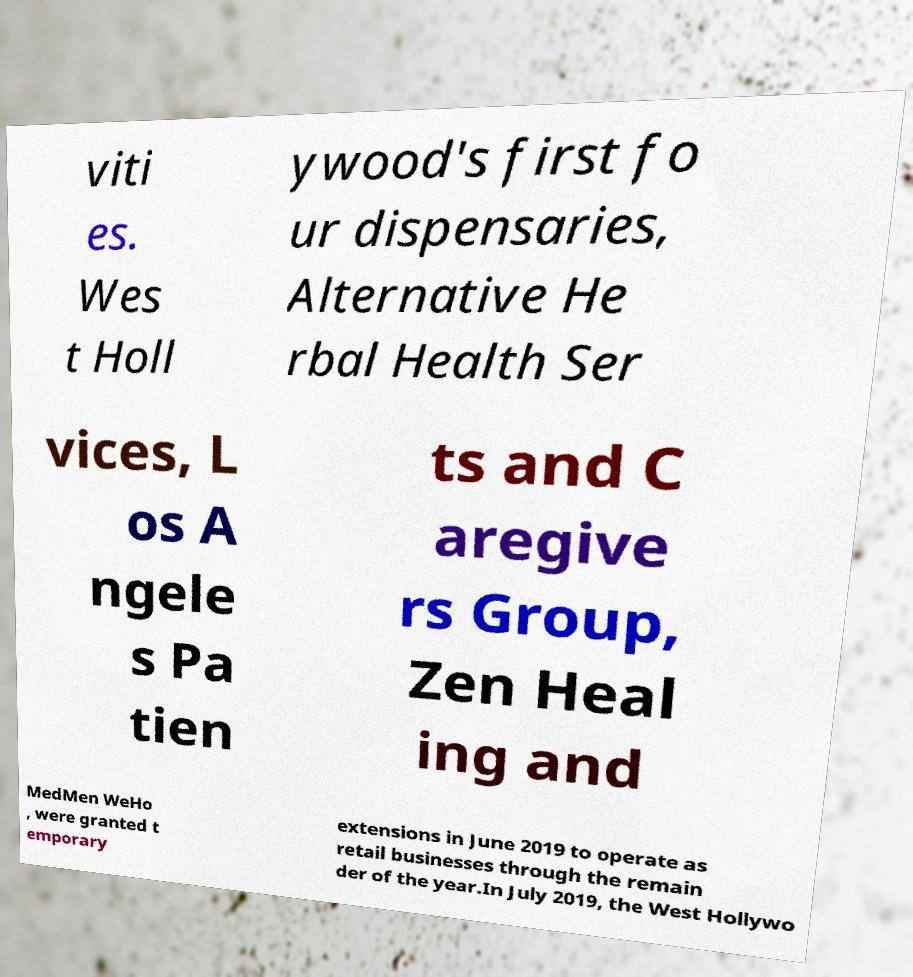Please identify and transcribe the text found in this image. viti es. Wes t Holl ywood's first fo ur dispensaries, Alternative He rbal Health Ser vices, L os A ngele s Pa tien ts and C aregive rs Group, Zen Heal ing and MedMen WeHo , were granted t emporary extensions in June 2019 to operate as retail businesses through the remain der of the year.In July 2019, the West Hollywo 